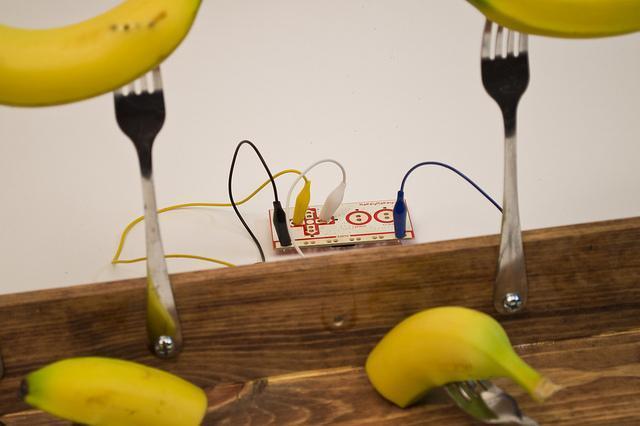How many pieces of fruit do you see?
Give a very brief answer. 4. How many forks are upright?
Give a very brief answer. 2. How many forks are there?
Give a very brief answer. 3. How many bananas can you see?
Give a very brief answer. 4. How many giraffes are there?
Give a very brief answer. 0. 